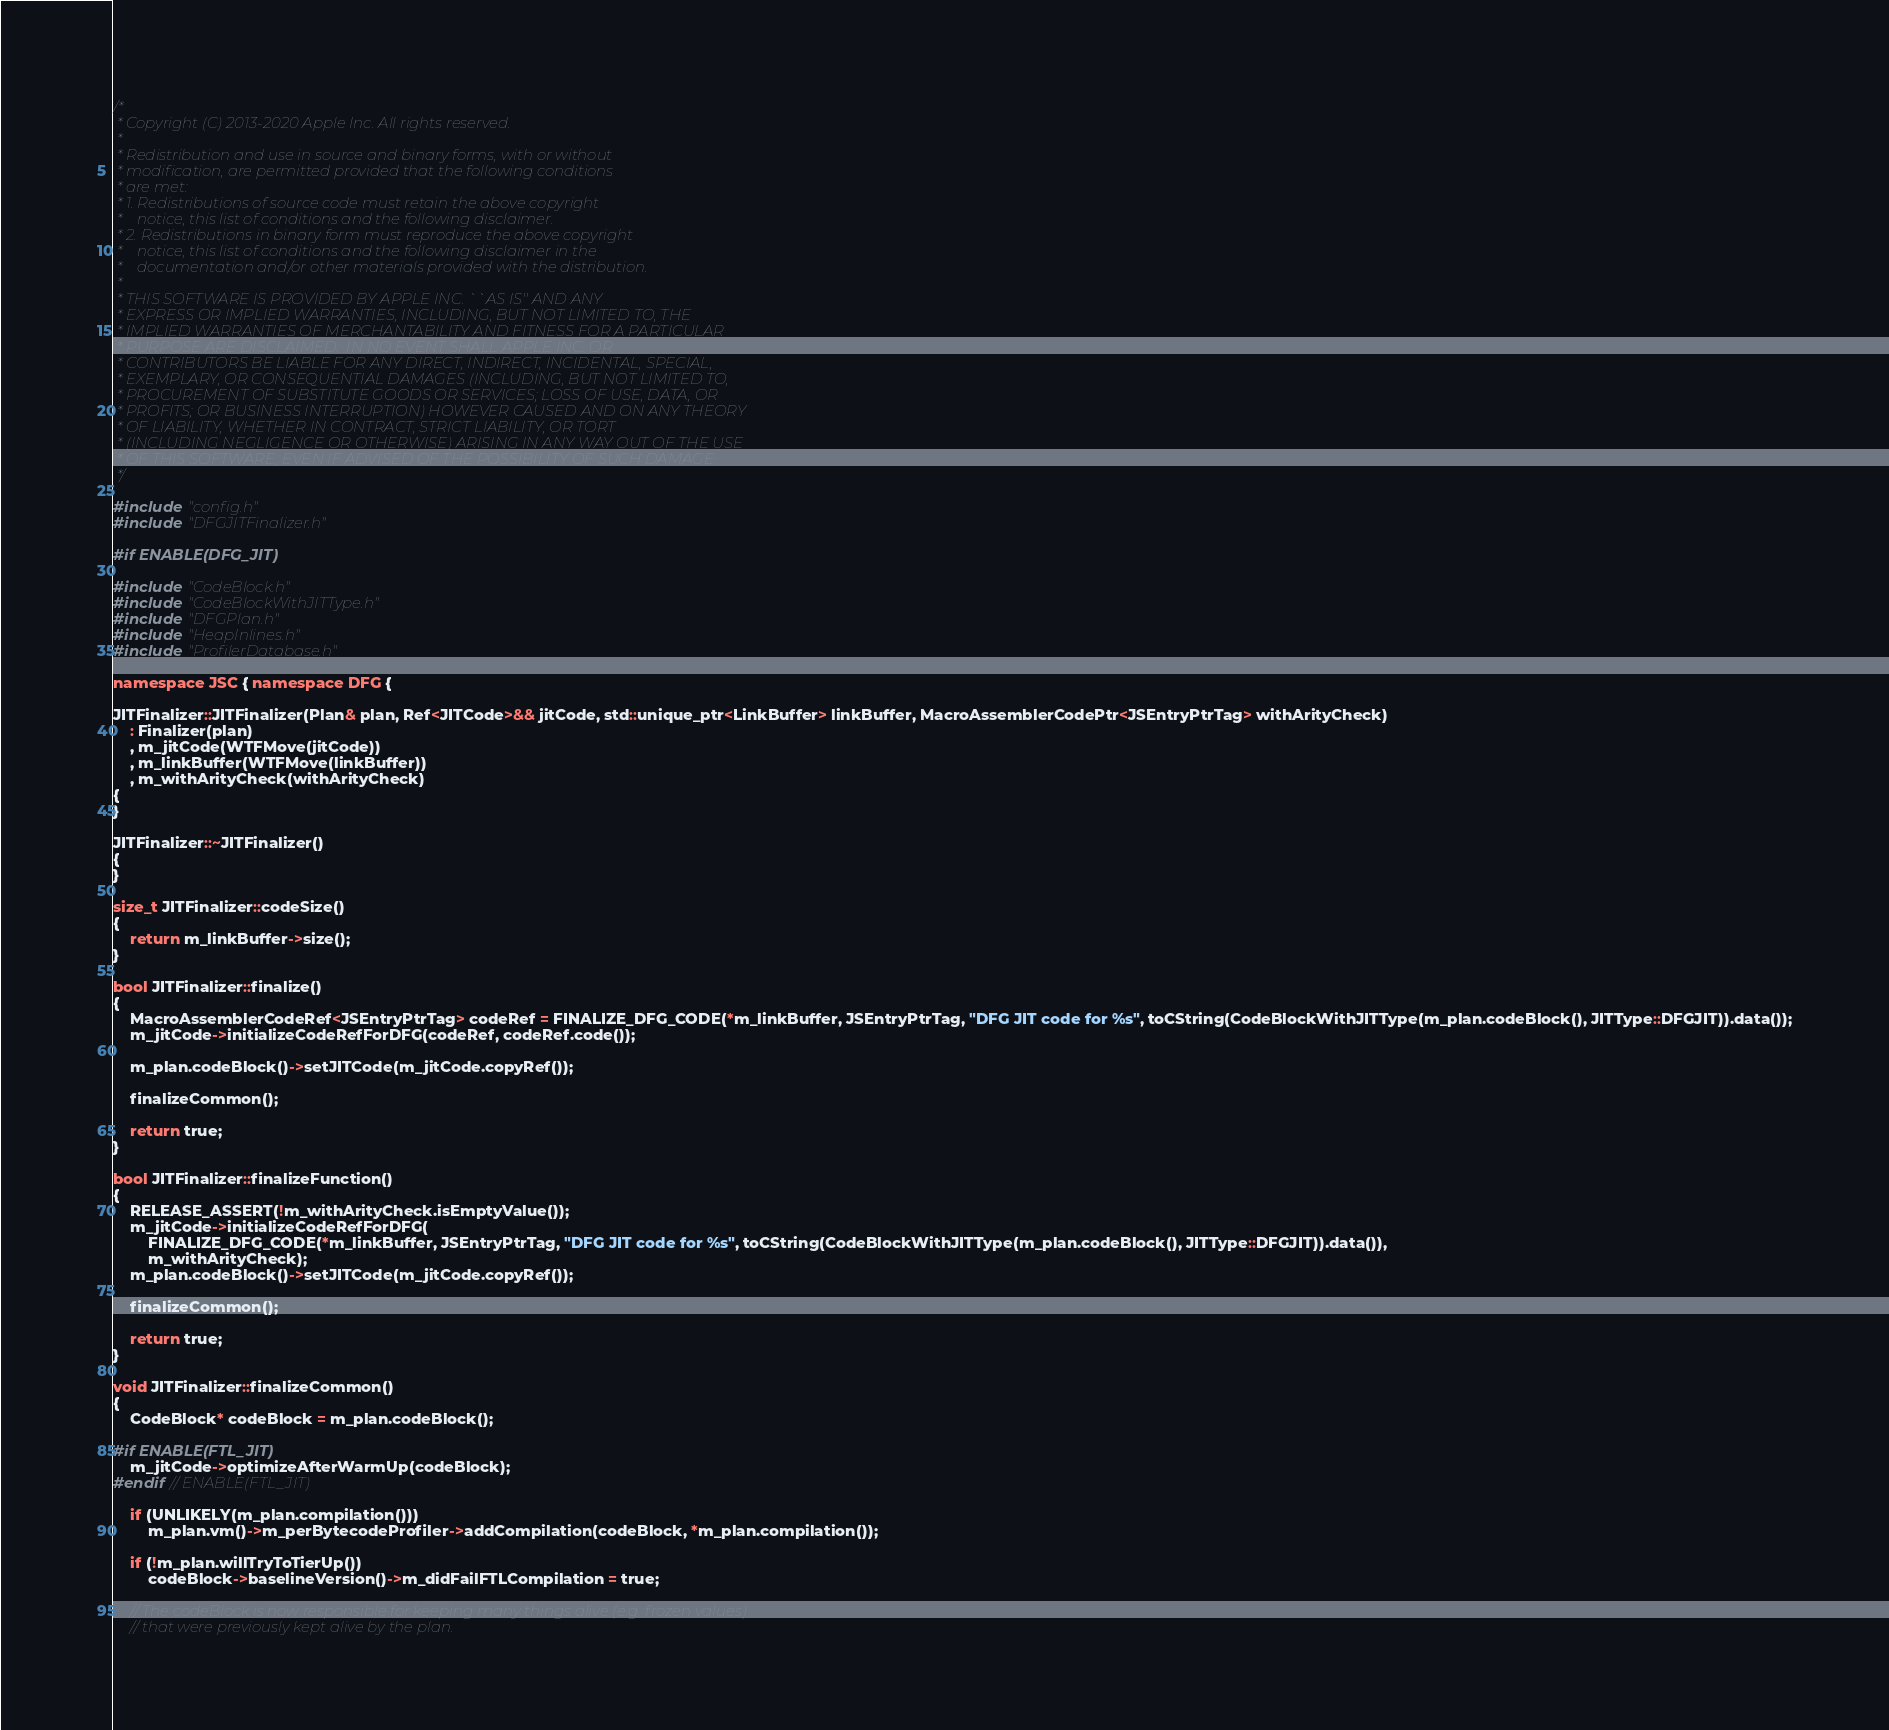Convert code to text. <code><loc_0><loc_0><loc_500><loc_500><_C++_>/*
 * Copyright (C) 2013-2020 Apple Inc. All rights reserved.
 *
 * Redistribution and use in source and binary forms, with or without
 * modification, are permitted provided that the following conditions
 * are met:
 * 1. Redistributions of source code must retain the above copyright
 *    notice, this list of conditions and the following disclaimer.
 * 2. Redistributions in binary form must reproduce the above copyright
 *    notice, this list of conditions and the following disclaimer in the
 *    documentation and/or other materials provided with the distribution.
 *
 * THIS SOFTWARE IS PROVIDED BY APPLE INC. ``AS IS'' AND ANY
 * EXPRESS OR IMPLIED WARRANTIES, INCLUDING, BUT NOT LIMITED TO, THE
 * IMPLIED WARRANTIES OF MERCHANTABILITY AND FITNESS FOR A PARTICULAR
 * PURPOSE ARE DISCLAIMED.  IN NO EVENT SHALL APPLE INC. OR
 * CONTRIBUTORS BE LIABLE FOR ANY DIRECT, INDIRECT, INCIDENTAL, SPECIAL,
 * EXEMPLARY, OR CONSEQUENTIAL DAMAGES (INCLUDING, BUT NOT LIMITED TO,
 * PROCUREMENT OF SUBSTITUTE GOODS OR SERVICES; LOSS OF USE, DATA, OR
 * PROFITS; OR BUSINESS INTERRUPTION) HOWEVER CAUSED AND ON ANY THEORY
 * OF LIABILITY, WHETHER IN CONTRACT, STRICT LIABILITY, OR TORT
 * (INCLUDING NEGLIGENCE OR OTHERWISE) ARISING IN ANY WAY OUT OF THE USE
 * OF THIS SOFTWARE, EVEN IF ADVISED OF THE POSSIBILITY OF SUCH DAMAGE. 
 */

#include "config.h"
#include "DFGJITFinalizer.h"

#if ENABLE(DFG_JIT)

#include "CodeBlock.h"
#include "CodeBlockWithJITType.h"
#include "DFGPlan.h"
#include "HeapInlines.h"
#include "ProfilerDatabase.h"

namespace JSC { namespace DFG {

JITFinalizer::JITFinalizer(Plan& plan, Ref<JITCode>&& jitCode, std::unique_ptr<LinkBuffer> linkBuffer, MacroAssemblerCodePtr<JSEntryPtrTag> withArityCheck)
    : Finalizer(plan)
    , m_jitCode(WTFMove(jitCode))
    , m_linkBuffer(WTFMove(linkBuffer))
    , m_withArityCheck(withArityCheck)
{
}

JITFinalizer::~JITFinalizer()
{
}

size_t JITFinalizer::codeSize()
{
    return m_linkBuffer->size();
}

bool JITFinalizer::finalize()
{
    MacroAssemblerCodeRef<JSEntryPtrTag> codeRef = FINALIZE_DFG_CODE(*m_linkBuffer, JSEntryPtrTag, "DFG JIT code for %s", toCString(CodeBlockWithJITType(m_plan.codeBlock(), JITType::DFGJIT)).data());
    m_jitCode->initializeCodeRefForDFG(codeRef, codeRef.code());

    m_plan.codeBlock()->setJITCode(m_jitCode.copyRef());

    finalizeCommon();
    
    return true;
}

bool JITFinalizer::finalizeFunction()
{
    RELEASE_ASSERT(!m_withArityCheck.isEmptyValue());
    m_jitCode->initializeCodeRefForDFG(
        FINALIZE_DFG_CODE(*m_linkBuffer, JSEntryPtrTag, "DFG JIT code for %s", toCString(CodeBlockWithJITType(m_plan.codeBlock(), JITType::DFGJIT)).data()),
        m_withArityCheck);
    m_plan.codeBlock()->setJITCode(m_jitCode.copyRef());

    finalizeCommon();
    
    return true;
}

void JITFinalizer::finalizeCommon()
{
    CodeBlock* codeBlock = m_plan.codeBlock();

#if ENABLE(FTL_JIT)
    m_jitCode->optimizeAfterWarmUp(codeBlock);
#endif // ENABLE(FTL_JIT)

    if (UNLIKELY(m_plan.compilation()))
        m_plan.vm()->m_perBytecodeProfiler->addCompilation(codeBlock, *m_plan.compilation());

    if (!m_plan.willTryToTierUp())
        codeBlock->baselineVersion()->m_didFailFTLCompilation = true;

    // The codeBlock is now responsible for keeping many things alive (e.g. frozen values)
    // that were previously kept alive by the plan.</code> 